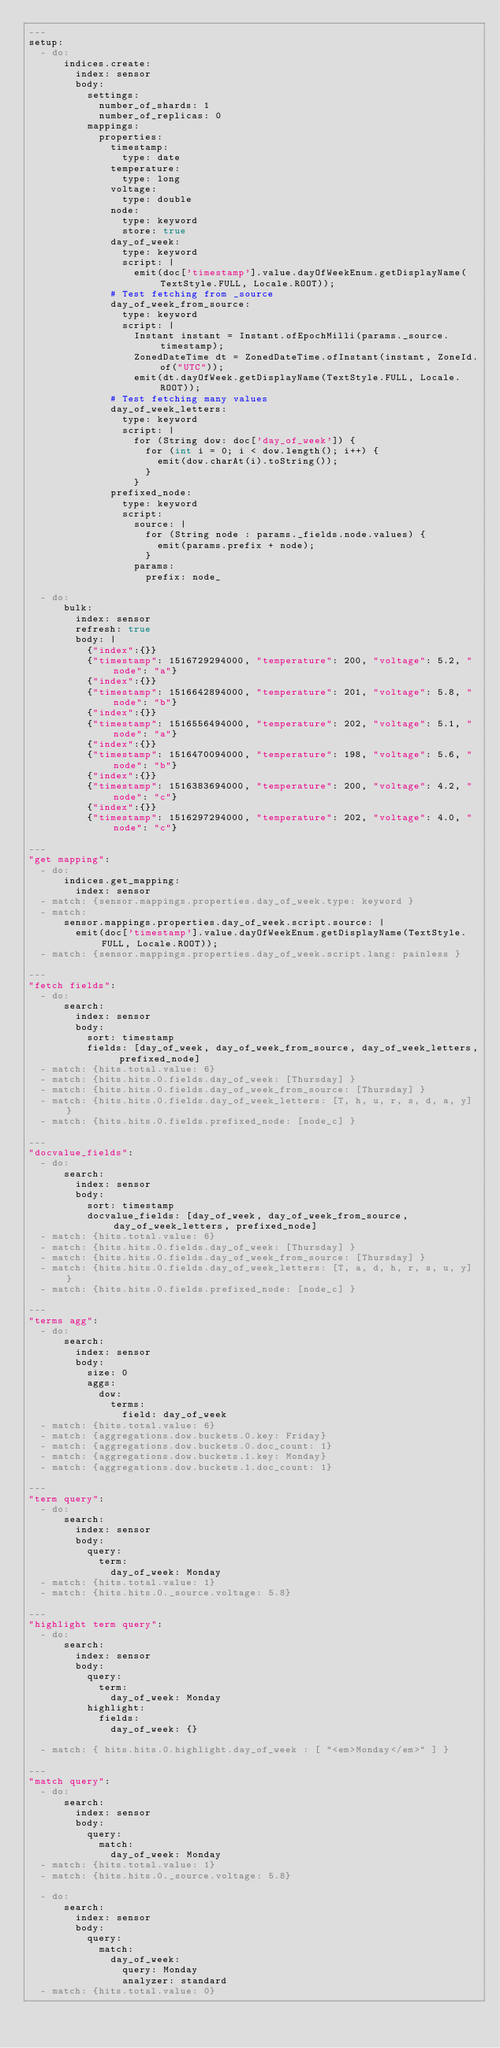<code> <loc_0><loc_0><loc_500><loc_500><_YAML_>---
setup:
  - do:
      indices.create:
        index: sensor
        body:
          settings:
            number_of_shards: 1
            number_of_replicas: 0
          mappings:
            properties:
              timestamp:
                type: date
              temperature:
                type: long
              voltage:
                type: double
              node:
                type: keyword
                store: true
              day_of_week:
                type: keyword
                script: |
                  emit(doc['timestamp'].value.dayOfWeekEnum.getDisplayName(TextStyle.FULL, Locale.ROOT));
              # Test fetching from _source
              day_of_week_from_source:
                type: keyword
                script: |
                  Instant instant = Instant.ofEpochMilli(params._source.timestamp);
                  ZonedDateTime dt = ZonedDateTime.ofInstant(instant, ZoneId.of("UTC"));
                  emit(dt.dayOfWeek.getDisplayName(TextStyle.FULL, Locale.ROOT));
              # Test fetching many values
              day_of_week_letters:
                type: keyword
                script: |
                  for (String dow: doc['day_of_week']) {
                    for (int i = 0; i < dow.length(); i++) {
                      emit(dow.charAt(i).toString());
                    }
                  }
              prefixed_node:
                type: keyword
                script:
                  source: |
                    for (String node : params._fields.node.values) {
                      emit(params.prefix + node);
                    }
                  params:
                    prefix: node_

  - do:
      bulk:
        index: sensor
        refresh: true
        body: |
          {"index":{}}
          {"timestamp": 1516729294000, "temperature": 200, "voltage": 5.2, "node": "a"}
          {"index":{}}
          {"timestamp": 1516642894000, "temperature": 201, "voltage": 5.8, "node": "b"}
          {"index":{}}
          {"timestamp": 1516556494000, "temperature": 202, "voltage": 5.1, "node": "a"}
          {"index":{}}
          {"timestamp": 1516470094000, "temperature": 198, "voltage": 5.6, "node": "b"}
          {"index":{}}
          {"timestamp": 1516383694000, "temperature": 200, "voltage": 4.2, "node": "c"}
          {"index":{}}
          {"timestamp": 1516297294000, "temperature": 202, "voltage": 4.0, "node": "c"}

---
"get mapping":
  - do:
      indices.get_mapping:
        index: sensor
  - match: {sensor.mappings.properties.day_of_week.type: keyword }
  - match:
      sensor.mappings.properties.day_of_week.script.source: |
        emit(doc['timestamp'].value.dayOfWeekEnum.getDisplayName(TextStyle.FULL, Locale.ROOT));
  - match: {sensor.mappings.properties.day_of_week.script.lang: painless }

---
"fetch fields":
  - do:
      search:
        index: sensor
        body:
          sort: timestamp
          fields: [day_of_week, day_of_week_from_source, day_of_week_letters, prefixed_node]
  - match: {hits.total.value: 6}
  - match: {hits.hits.0.fields.day_of_week: [Thursday] }
  - match: {hits.hits.0.fields.day_of_week_from_source: [Thursday] }
  - match: {hits.hits.0.fields.day_of_week_letters: [T, h, u, r, s, d, a, y] }
  - match: {hits.hits.0.fields.prefixed_node: [node_c] }

---
"docvalue_fields":
  - do:
      search:
        index: sensor
        body:
          sort: timestamp
          docvalue_fields: [day_of_week, day_of_week_from_source, day_of_week_letters, prefixed_node]
  - match: {hits.total.value: 6}
  - match: {hits.hits.0.fields.day_of_week: [Thursday] }
  - match: {hits.hits.0.fields.day_of_week_from_source: [Thursday] }
  - match: {hits.hits.0.fields.day_of_week_letters: [T, a, d, h, r, s, u, y] }
  - match: {hits.hits.0.fields.prefixed_node: [node_c] }

---
"terms agg":
  - do:
      search:
        index: sensor
        body:
          size: 0
          aggs:
            dow:
              terms:
                field: day_of_week
  - match: {hits.total.value: 6}
  - match: {aggregations.dow.buckets.0.key: Friday}
  - match: {aggregations.dow.buckets.0.doc_count: 1}
  - match: {aggregations.dow.buckets.1.key: Monday}
  - match: {aggregations.dow.buckets.1.doc_count: 1}

---
"term query":
  - do:
      search:
        index: sensor
        body:
          query:
            term:
              day_of_week: Monday
  - match: {hits.total.value: 1}
  - match: {hits.hits.0._source.voltage: 5.8}

---
"highlight term query":
  - do:
      search:
        index: sensor
        body:
          query:
            term:
              day_of_week: Monday
          highlight:
            fields:
              day_of_week: {}

  - match: { hits.hits.0.highlight.day_of_week : [ "<em>Monday</em>" ] }

---
"match query":
  - do:
      search:
        index: sensor
        body:
          query:
            match:
              day_of_week: Monday
  - match: {hits.total.value: 1}
  - match: {hits.hits.0._source.voltage: 5.8}

  - do:
      search:
        index: sensor
        body:
          query:
            match:
              day_of_week:
                query: Monday
                analyzer: standard
  - match: {hits.total.value: 0}
</code> 